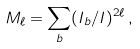Convert formula to latex. <formula><loc_0><loc_0><loc_500><loc_500>M _ { \ell } = \sum _ { b } ( I _ { b } / I ) ^ { 2 \ell } \, ,</formula> 